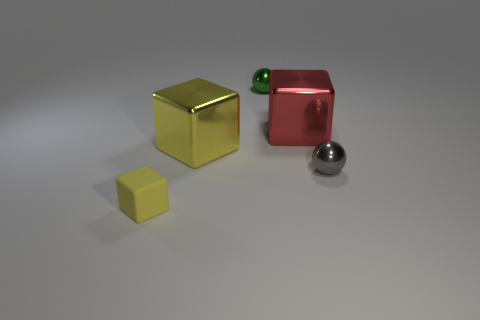Subtract all cyan spheres. How many yellow blocks are left? 2 Add 3 tiny gray rubber things. How many objects exist? 8 Subtract all large yellow cubes. How many cubes are left? 2 Subtract all spheres. How many objects are left? 3 Subtract 1 blocks. How many blocks are left? 2 Add 2 rubber blocks. How many rubber blocks are left? 3 Add 5 green things. How many green things exist? 6 Subtract 0 cyan cylinders. How many objects are left? 5 Subtract all brown balls. Subtract all green cubes. How many balls are left? 2 Subtract all small things. Subtract all tiny metallic objects. How many objects are left? 0 